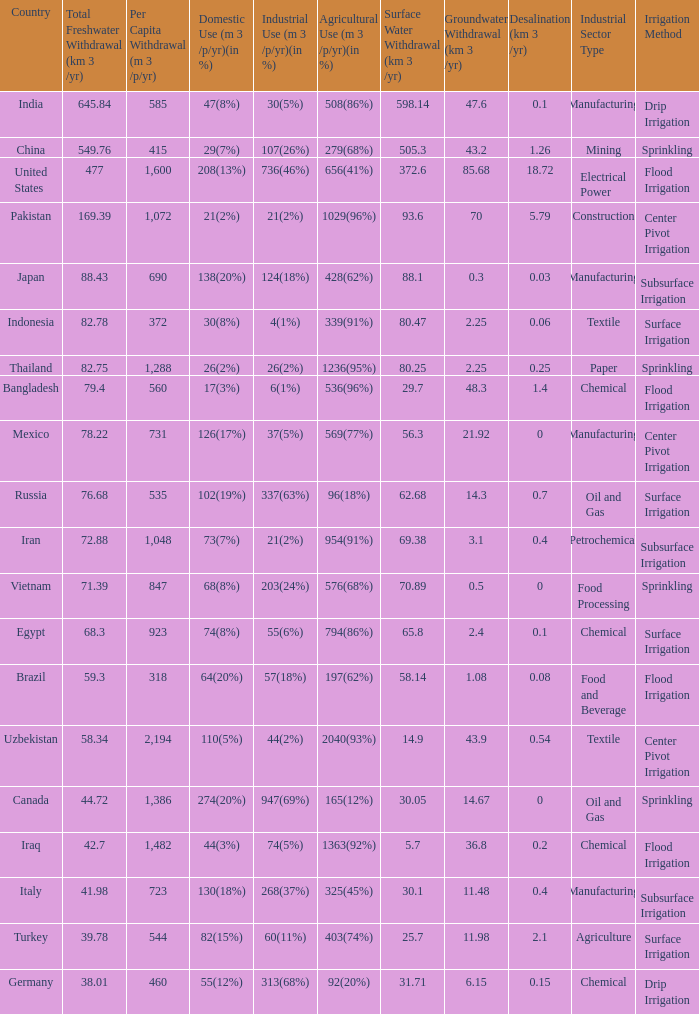What is Industrial Use (m 3 /p/yr)(in %), when Total Freshwater Withdrawal (km 3/yr) is less than 82.75, and when Agricultural Use (m 3 /p/yr)(in %) is 1363(92%)? 74(5%). 